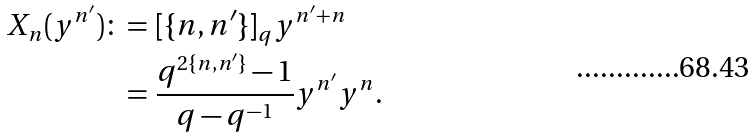Convert formula to latex. <formula><loc_0><loc_0><loc_500><loc_500>X _ { n } ( y ^ { n ^ { \prime } } ) \colon = & \ [ \{ n , n ^ { \prime } \} ] _ { q } y ^ { n ^ { \prime } + n } \\ = & \ \frac { q ^ { 2 \{ n , n ^ { \prime } \} } - 1 } { q - q ^ { - 1 } } y ^ { n ^ { \prime } } y ^ { n } .</formula> 